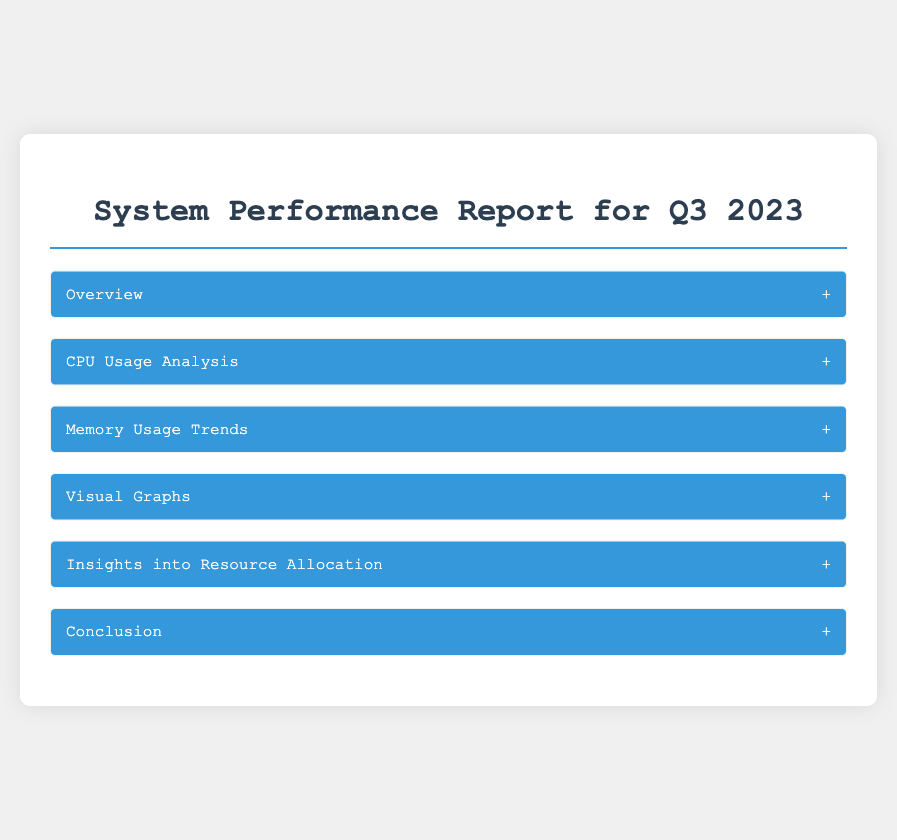What is the average CPU utilization in Q3 2023? The average CPU utilization across the primary servers in Q3 2023 is mentioned as 65%.
Answer: 65% What is the peak CPU usage time? The peak usage time is specified as during operational hours from 12 PM to 2 PM.
Answer: 12 PM to 2 PM What was the average memory usage across 'Data Warehouse Server 1'? The average memory usage across 'Data Warehouse Server 1' is stated as 75%.
Answer: 75% What phenomenon is noted during the processing of quarterly analytics? Significant variance in memory consumption is noted during the processing of quarterly analytics reports.
Answer: Significant variance Which project led to an increase in CPU utilization? The increase in CPU utilization is associated with the implementation of 'Project Orion'.
Answer: Project Orion What is the recommendation for 'Mail Server A'? The recommendation for 'Mail Server A' includes reevaluating resource distribution to enhance performance efficiency.
Answer: Reevaluating resource distribution What is emphasized as critical for accommodating evolving demands? Continued monitoring and adjustment of both CPU and memory allocations is emphasized.
Answer: Continued monitoring What type of graphs are presented in the report? The report includes a line graph for CPU utilization and a bar graph for memory usage distribution.
Answer: Line and bar graphs What is the overall conclusion of the report? The Q3 2023 performance analysis underscores the need for strategic resource management.
Answer: Strategic resource management 